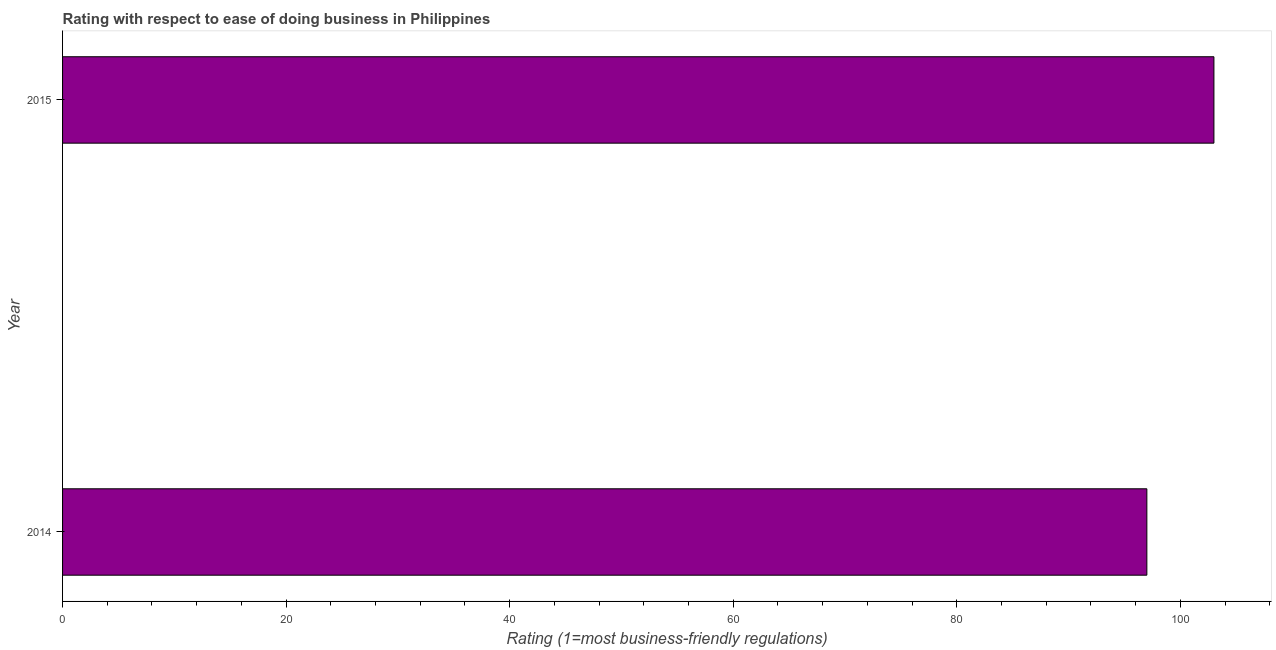What is the title of the graph?
Provide a succinct answer. Rating with respect to ease of doing business in Philippines. What is the label or title of the X-axis?
Your answer should be compact. Rating (1=most business-friendly regulations). What is the ease of doing business index in 2015?
Give a very brief answer. 103. Across all years, what is the maximum ease of doing business index?
Keep it short and to the point. 103. Across all years, what is the minimum ease of doing business index?
Make the answer very short. 97. In which year was the ease of doing business index maximum?
Offer a terse response. 2015. In which year was the ease of doing business index minimum?
Ensure brevity in your answer.  2014. What is the difference between the ease of doing business index in 2014 and 2015?
Your response must be concise. -6. What is the average ease of doing business index per year?
Give a very brief answer. 100. In how many years, is the ease of doing business index greater than 40 ?
Your answer should be very brief. 2. What is the ratio of the ease of doing business index in 2014 to that in 2015?
Offer a terse response. 0.94. In how many years, is the ease of doing business index greater than the average ease of doing business index taken over all years?
Your answer should be compact. 1. What is the difference between two consecutive major ticks on the X-axis?
Give a very brief answer. 20. Are the values on the major ticks of X-axis written in scientific E-notation?
Offer a terse response. No. What is the Rating (1=most business-friendly regulations) of 2014?
Offer a terse response. 97. What is the Rating (1=most business-friendly regulations) of 2015?
Your answer should be very brief. 103. What is the ratio of the Rating (1=most business-friendly regulations) in 2014 to that in 2015?
Ensure brevity in your answer.  0.94. 